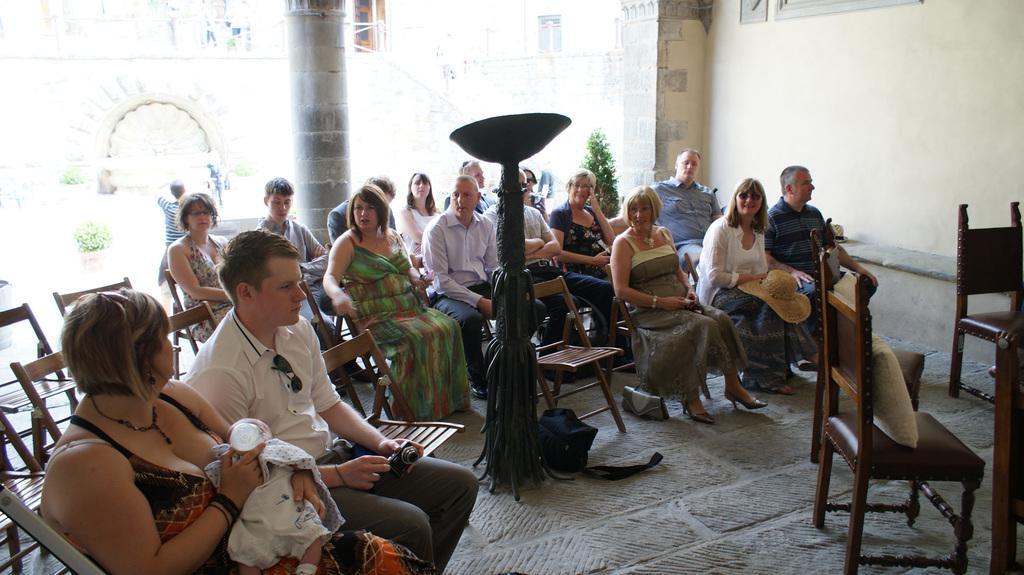In one or two sentences, can you explain what this image depicts? In this image I can see there are few persons sitting on chairs and I can see two chairs on the left side , in the middle I can see a pole and a bag on the floor, in the foreground I can see a woman holding a baby and bottle and beside the woman I can see a man holding a camera and at the top I can see the beam and on the right side I can see the wall and I can see a building and a person and flowerpot visible in the background. 